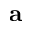<formula> <loc_0><loc_0><loc_500><loc_500>a</formula> 